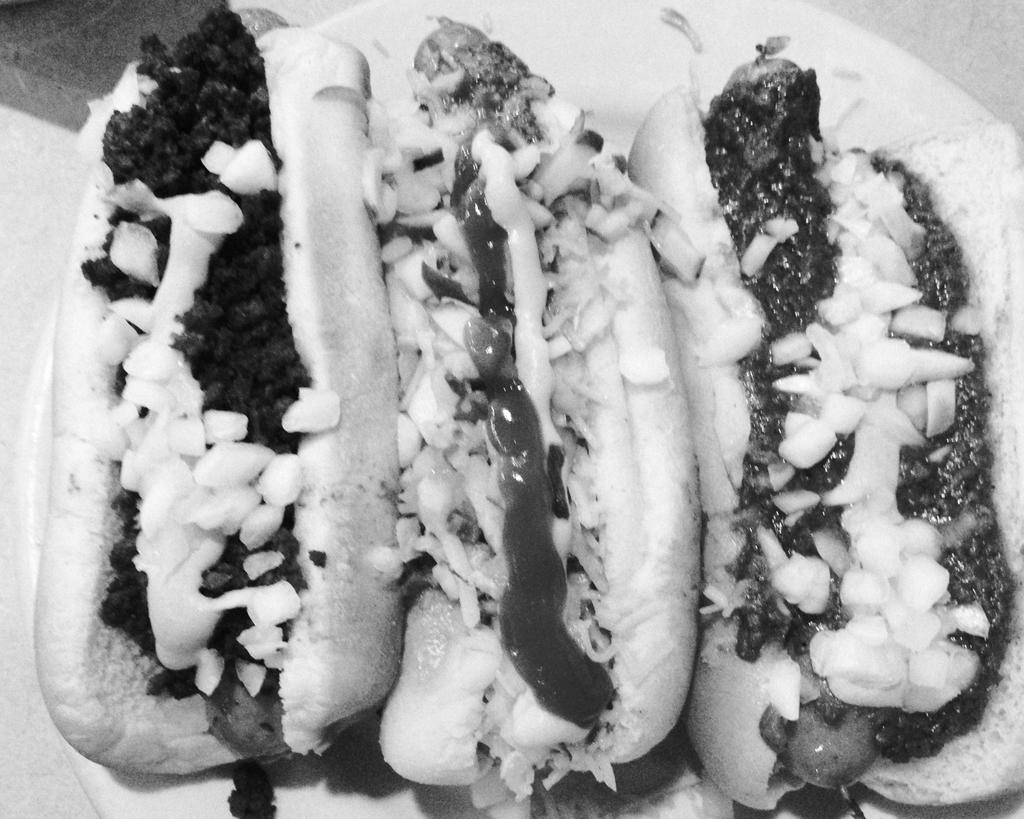What type of food can be seen in the image? There are sandwiches and a hot dog in the image. How does the anger in the image affect the size of the sandwiches? There is no anger present in the image, and therefore it cannot affect the size of the sandwiches. 